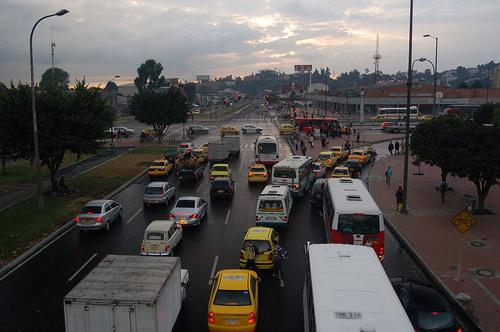What picture is on the sign that is all the way to the right? bicycle 